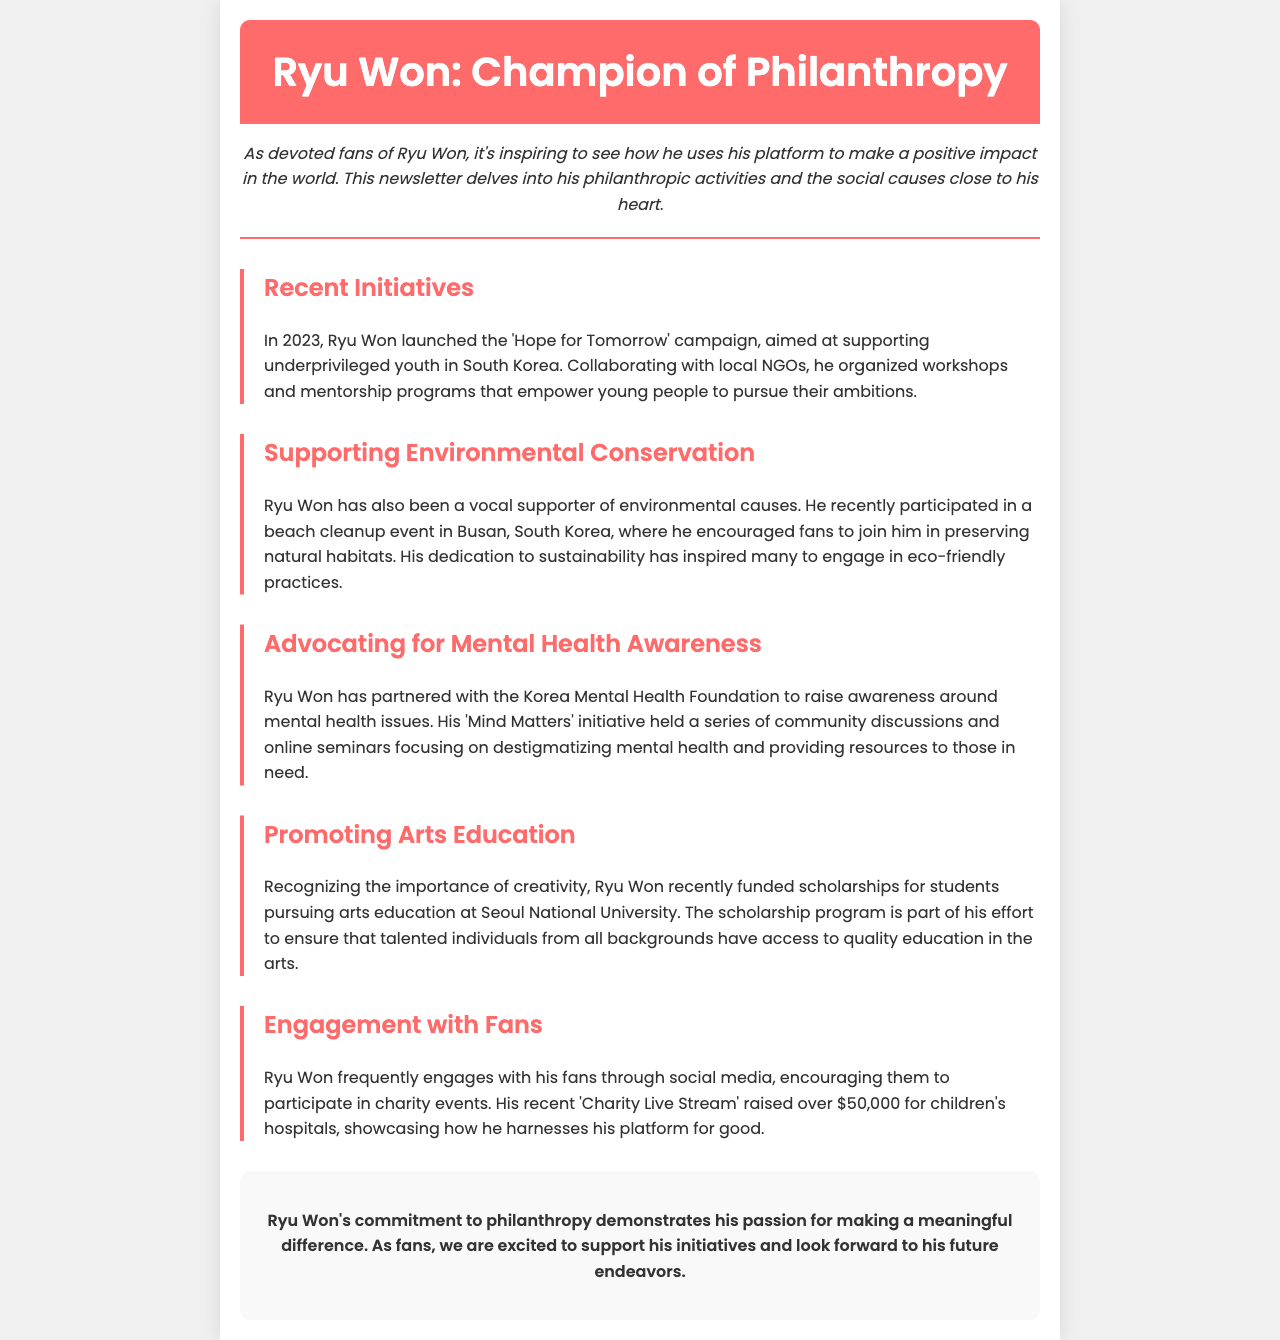What is the name of Ryu Won's campaign launched in 2023? The document states that Ryu Won launched the 'Hope for Tomorrow' campaign in 2023.
Answer: Hope for Tomorrow What cause does Ryu Won support related to youth? Ryu Won's campaign 'Hope for Tomorrow' focuses on supporting underprivileged youth.
Answer: Underprivileged youth Which event did Ryu Won participate in to support environmental conservation? The document mentions that Ryu Won participated in a beach cleanup event in Busan, South Korea.
Answer: Beach cleanup What initiative did Ryu Won partner with the Korea Mental Health Foundation to promote? The initiative conducted by Ryu Won in collaboration with the foundation is called 'Mind Matters'.
Answer: Mind Matters How much money was raised during Ryu Won's 'Charity Live Stream'? The document states that the 'Charity Live Stream' raised over $50,000.
Answer: Over $50,000 What is the main focus of the scholarships Ryu Won funded? According to the document, the scholarships are for students pursuing arts education at Seoul National University.
Answer: Arts education What is the main goal of Ryu Won's 'Mind Matters' initiative? The goal of the 'Mind Matters' initiative is to destigmatize mental health and provide resources.
Answer: Destigmatizing mental health In which year did Ryu Won launch the 'Hope for Tomorrow' campaign? The document specifies that the campaign was launched in 2023.
Answer: 2023 What is the primary means through which Ryu Won engages with fans for charity? Ryu Won engages with fans through a 'Charity Live Stream' to raise funds for charity.
Answer: Charity Live Stream 